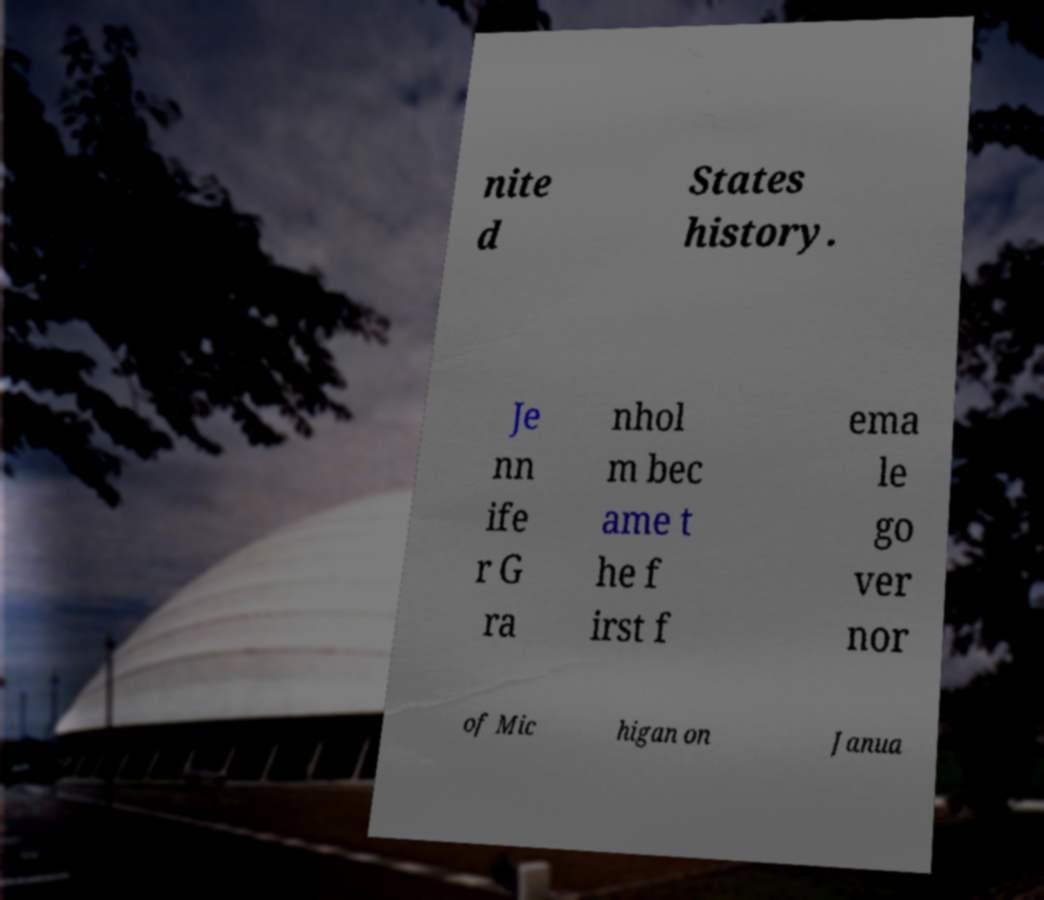Could you assist in decoding the text presented in this image and type it out clearly? nite d States history. Je nn ife r G ra nhol m bec ame t he f irst f ema le go ver nor of Mic higan on Janua 